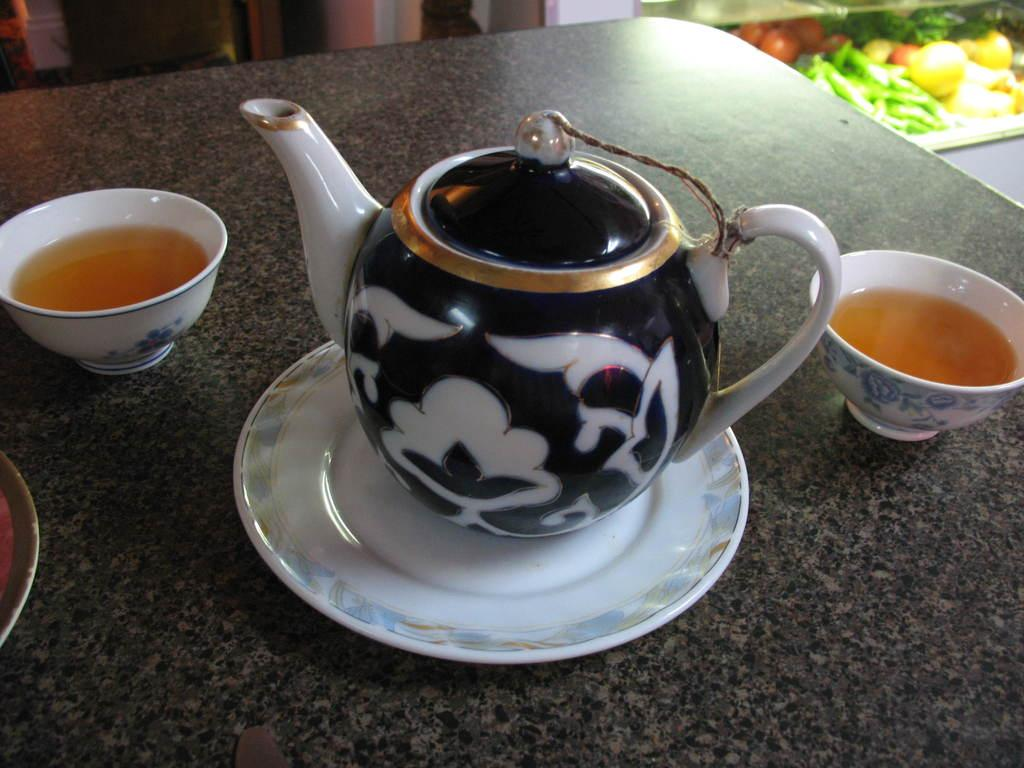What is the main object in the image? There is a teapot in the image. What other objects are present with the teapot? There are plates and cups in the image. Where are the teapot, plates, and cups located? They are on a table. What can be seen in the background of the image? There are vegetables visible in the background. What type of apparel is being worn by the vegetables in the image? There are no people or apparel present in the image; it features a teapot, plates, cups, and vegetables. What is the lead content of the teapot in the image? The lead content of the teapot cannot be determined from the image alone. 